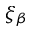<formula> <loc_0><loc_0><loc_500><loc_500>\xi _ { \beta }</formula> 